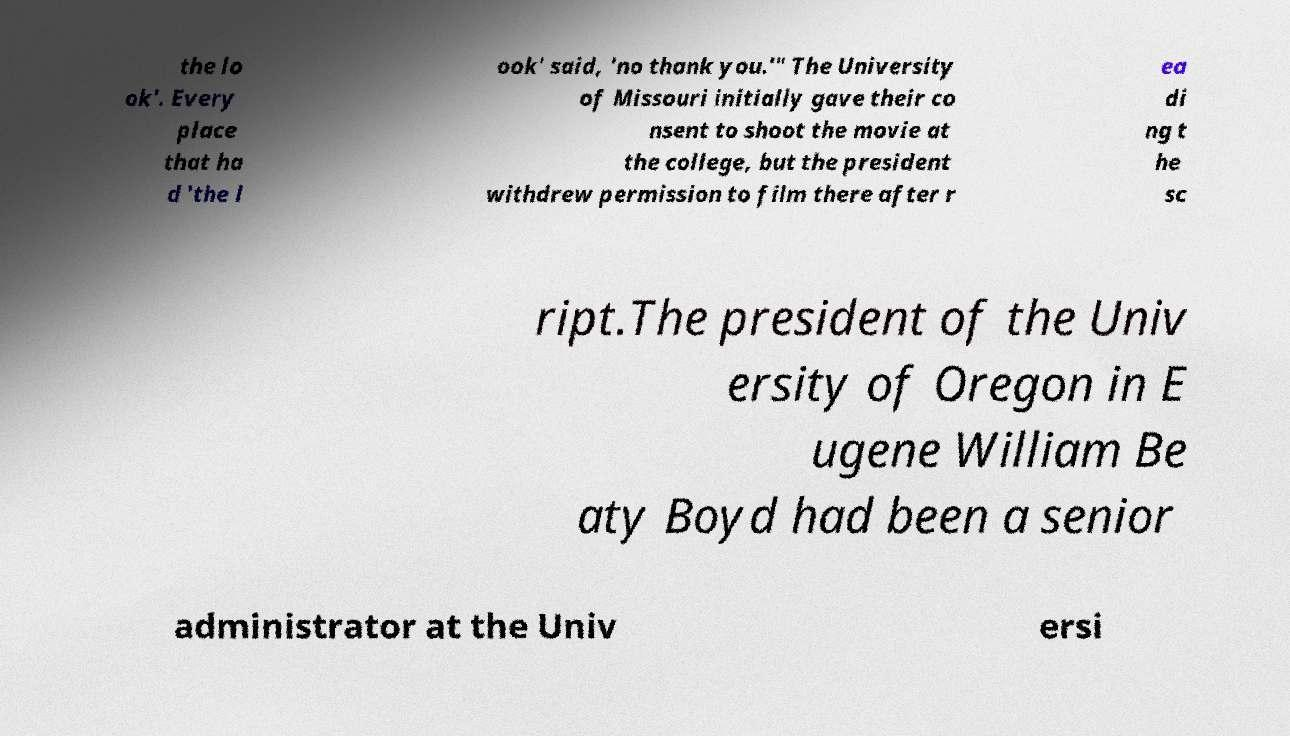There's text embedded in this image that I need extracted. Can you transcribe it verbatim? the lo ok'. Every place that ha d 'the l ook' said, 'no thank you.'" The University of Missouri initially gave their co nsent to shoot the movie at the college, but the president withdrew permission to film there after r ea di ng t he sc ript.The president of the Univ ersity of Oregon in E ugene William Be aty Boyd had been a senior administrator at the Univ ersi 